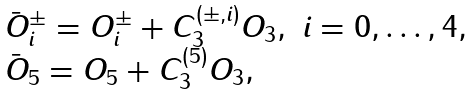Convert formula to latex. <formula><loc_0><loc_0><loc_500><loc_500>\begin{array} { l } \bar { O } ^ { \pm } _ { i } = O ^ { \pm } _ { i } + C ^ { ( \pm , i ) } _ { 3 } O _ { 3 } , \ i = 0 , \dots , 4 , \\ \bar { O } _ { 5 } = O _ { 5 } + C ^ { ( 5 ) } _ { 3 } O _ { 3 } , \end{array}</formula> 